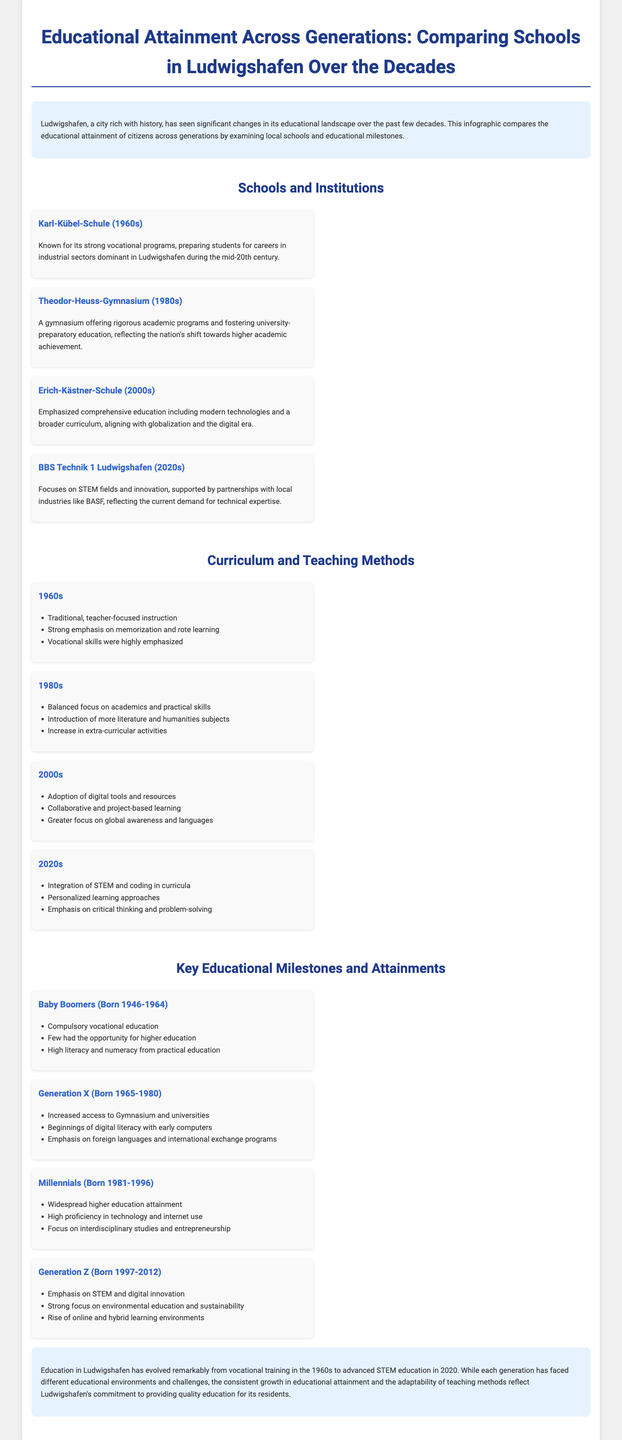what school is known for its strong vocational programs in the 1960s? The document specifically mentions Karl-Kübel-Schule as known for its strong vocational programs.
Answer: Karl-Kübel-Schule which generation saw increased access to Gymnasium and universities? The document states that Generation X had increased access to Gymnasium and universities.
Answer: Generation X what decade emphasized comprehensive education and modern technologies? The document indicates that the 2000s emphasized comprehensive education including modern technologies.
Answer: 2000s how did teaching methods change in the 2020s? The document outlines that the 2020s incorporated integration of STEM and coding in curricula, alongside personalized learning approaches.
Answer: STEM and coding what significant milestone did Baby Boomers face regarding higher education? The document mentions that few Baby Boomers had the opportunity for higher education.
Answer: Few what is the focus of BBS Technik 1 Ludwigshafen in the 2020s? According to the document, BBS Technik 1 Ludwigshafen focuses on STEM fields and innovation.
Answer: STEM fields and innovation which generation emphasized environmental education and sustainability? The document indicates that Generation Z had a strong focus on environmental education and sustainability.
Answer: Generation Z what was a key emphasis in the 1980s curriculum? The document states that the 1980s had a balanced focus on academics and practical skills.
Answer: Balanced focus on academics and practical skills 